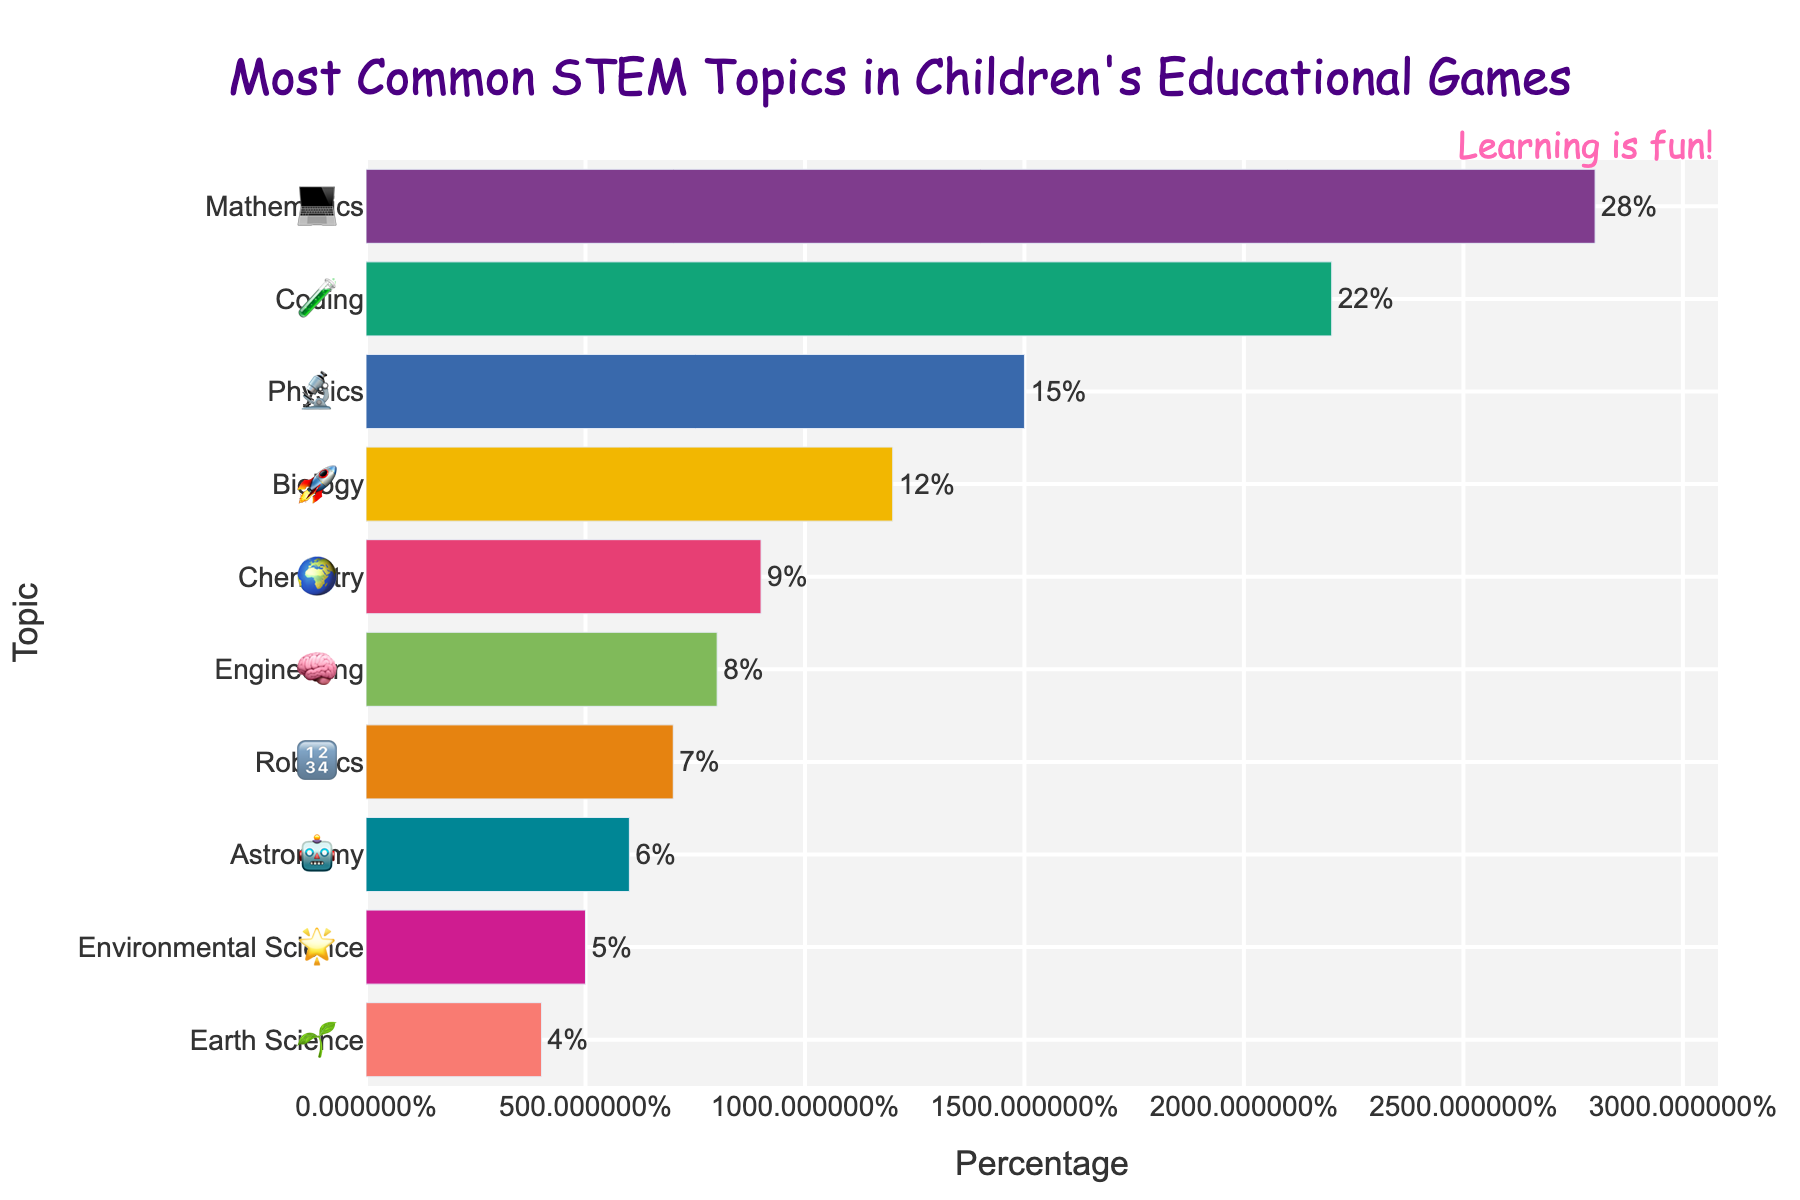Which STEM topic has the highest percentage? By looking at the figure, the bar representing Mathematics is the longest and highest in percentage, standing at 28%.
Answer: Mathematics Which two STEM topics combined cover more than 50% of the topics? By examining the percentages, Mathematics (28%) and Coding (22%) add up to 50%, which is precisely half. Any larger combinations will exceed 50%.
Answer: Mathematics and Coding How many topics have a percentage lower than 10%? By counting the bars with percentages less than 10%, we see Chemistry (9%), Engineering (8%), Robotics (7%), Astronomy (6%), Environmental Science (5%), and Earth Science (4%), resulting in six topics.
Answer: 6 What is the total percentage covered by Physics, Astronomy, and Earth Science? Adding the percentages: Physics (15%) + Astronomy (6%) + Earth Science (4%) = 25%.
Answer: 25% Which topic has the smallest percentage and by what percentage is it smaller than Chemistry? The smallest percentage bar represents Earth Science with 4%. The difference with Chemistry (9%) is calculated as 9% - 4% = 5%.
Answer: Earth Science, 5% Is there an equal number of topics above and below 10%? Counting topics above 10%: Mathematics, Coding, Physics, and Biology (4 topics). Counting topics below 10%: Chemistry, Engineering, Robotics, Astronomy, Environmental Science, and Earth Science (6 topics). There are not equal numbers above and below 10%.
Answer: No What is the average percentage of the top three most common topics? Percentages for the top three topics are Mathematics (28%), Coding (22%), and Physics (15%). The average is calculated as (28% + 22% + 15%) / 3 = 65% / 3 = approximately 21.67%.
Answer: Approximately 21.67% Which topic has a percentage closest to the median percentage of all topics? First, list all percentages in ascending order: 4%, 5%, 6%, 7%, 8%, 9%, 12%, 15%, 22%, 28%. Since there are 10 topics, the median will be the average of the 5th and 6th values: (8% + 9%) / 2 = 8.5%. Environmental Science (8%) is closest to the median.
Answer: Engineering 